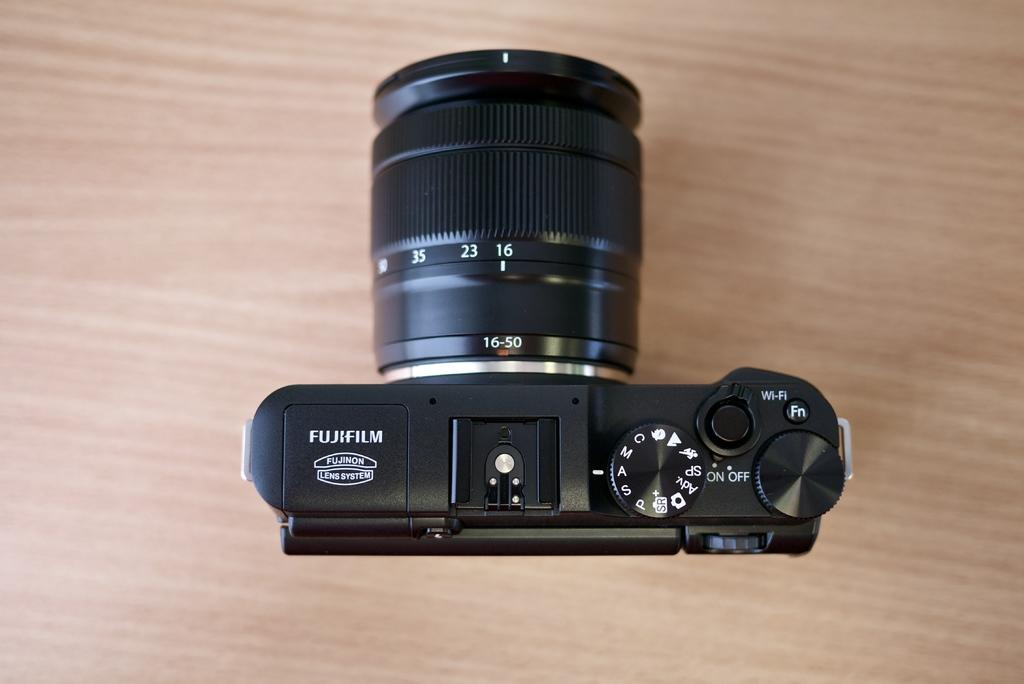What is the perspective of the image? The image is taken from a top view. What object is visible on the wooden surface? There is a camera on the wooden surface. What feature does the camera have? The camera has buttons. What type of information can be found on the camera? There are numbers, alphabets, and text on the camera. What degree does the camera need to be tilted to capture the perfect shot? The image does not provide information about the camera's angle or the need to tilt it for a perfect shot. 